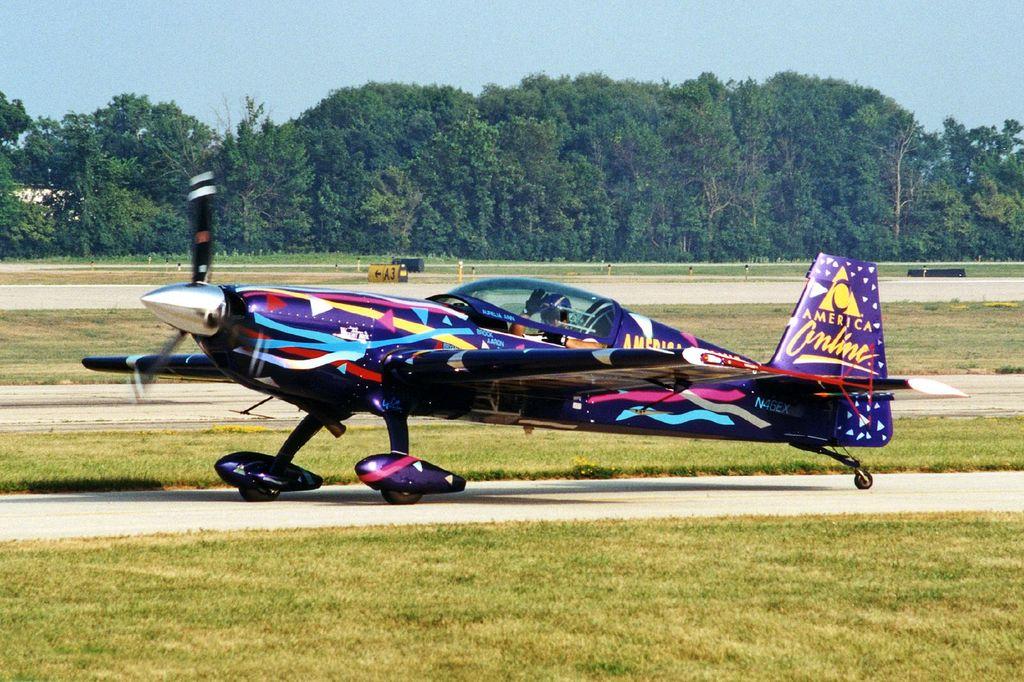What company is displayed on the tail wing?
Make the answer very short. America online. 